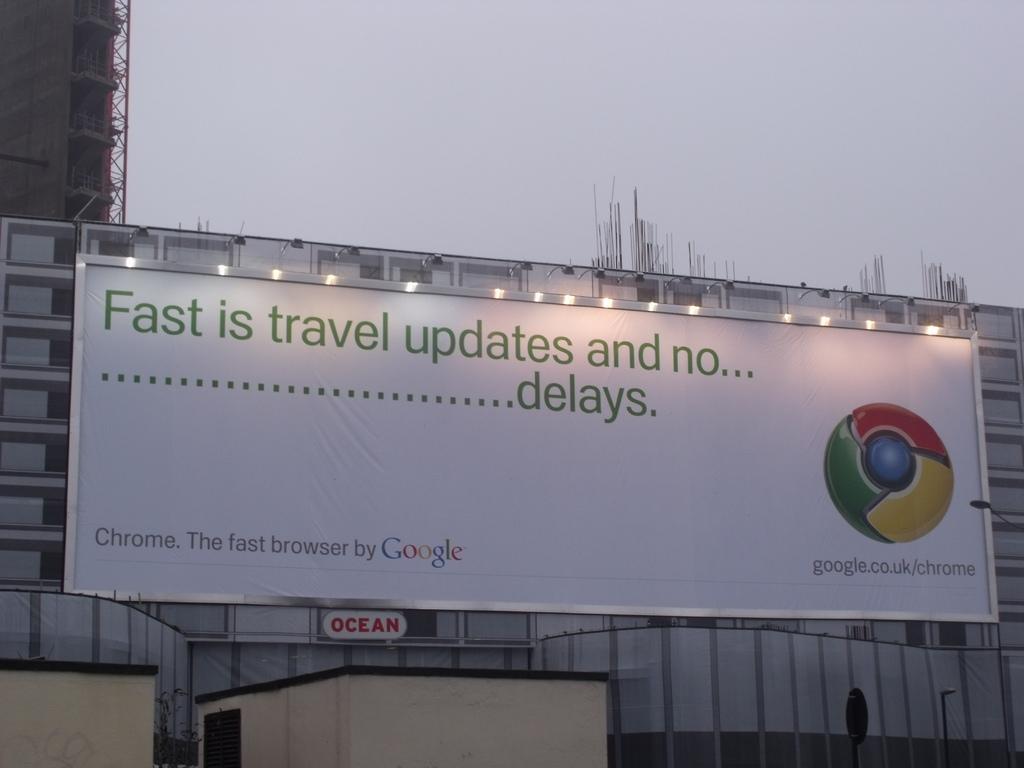How would you summarize this image in a sentence or two? In this image, in the middle there is a banner on that there is a text and logo, lights. In the background there are buildings, sky. 